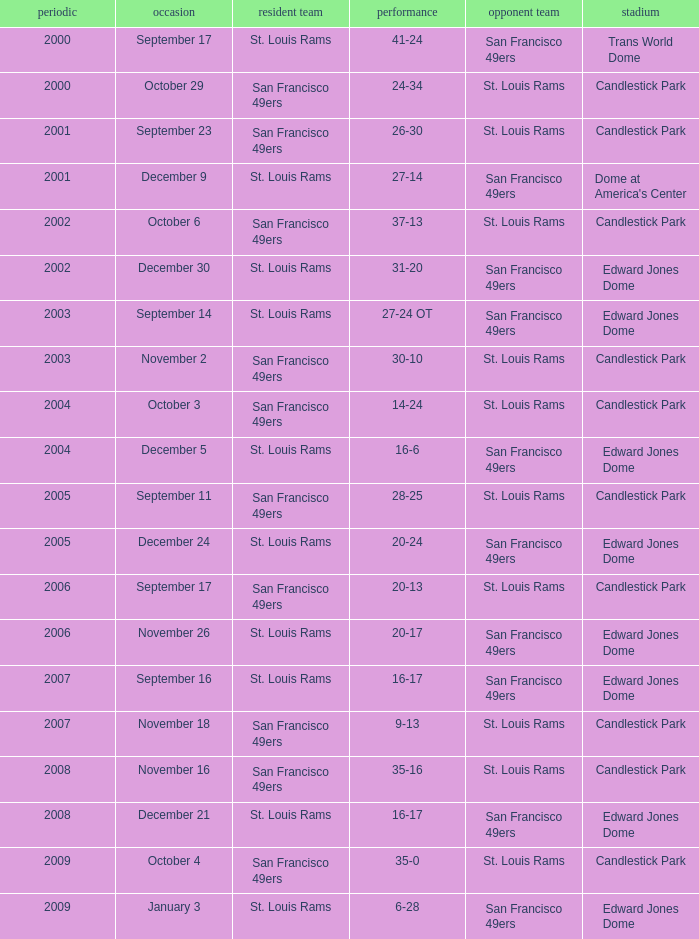Write the full table. {'header': ['periodic', 'occasion', 'resident team', 'performance', 'opponent team', 'stadium'], 'rows': [['2000', 'September 17', 'St. Louis Rams', '41-24', 'San Francisco 49ers', 'Trans World Dome'], ['2000', 'October 29', 'San Francisco 49ers', '24-34', 'St. Louis Rams', 'Candlestick Park'], ['2001', 'September 23', 'San Francisco 49ers', '26-30', 'St. Louis Rams', 'Candlestick Park'], ['2001', 'December 9', 'St. Louis Rams', '27-14', 'San Francisco 49ers', "Dome at America's Center"], ['2002', 'October 6', 'San Francisco 49ers', '37-13', 'St. Louis Rams', 'Candlestick Park'], ['2002', 'December 30', 'St. Louis Rams', '31-20', 'San Francisco 49ers', 'Edward Jones Dome'], ['2003', 'September 14', 'St. Louis Rams', '27-24 OT', 'San Francisco 49ers', 'Edward Jones Dome'], ['2003', 'November 2', 'San Francisco 49ers', '30-10', 'St. Louis Rams', 'Candlestick Park'], ['2004', 'October 3', 'San Francisco 49ers', '14-24', 'St. Louis Rams', 'Candlestick Park'], ['2004', 'December 5', 'St. Louis Rams', '16-6', 'San Francisco 49ers', 'Edward Jones Dome'], ['2005', 'September 11', 'San Francisco 49ers', '28-25', 'St. Louis Rams', 'Candlestick Park'], ['2005', 'December 24', 'St. Louis Rams', '20-24', 'San Francisco 49ers', 'Edward Jones Dome'], ['2006', 'September 17', 'San Francisco 49ers', '20-13', 'St. Louis Rams', 'Candlestick Park'], ['2006', 'November 26', 'St. Louis Rams', '20-17', 'San Francisco 49ers', 'Edward Jones Dome'], ['2007', 'September 16', 'St. Louis Rams', '16-17', 'San Francisco 49ers', 'Edward Jones Dome'], ['2007', 'November 18', 'San Francisco 49ers', '9-13', 'St. Louis Rams', 'Candlestick Park'], ['2008', 'November 16', 'San Francisco 49ers', '35-16', 'St. Louis Rams', 'Candlestick Park'], ['2008', 'December 21', 'St. Louis Rams', '16-17', 'San Francisco 49ers', 'Edward Jones Dome'], ['2009', 'October 4', 'San Francisco 49ers', '35-0', 'St. Louis Rams', 'Candlestick Park'], ['2009', 'January 3', 'St. Louis Rams', '6-28', 'San Francisco 49ers', 'Edward Jones Dome']]} What is the Venue of the 2009 St. Louis Rams Home game? Edward Jones Dome. 